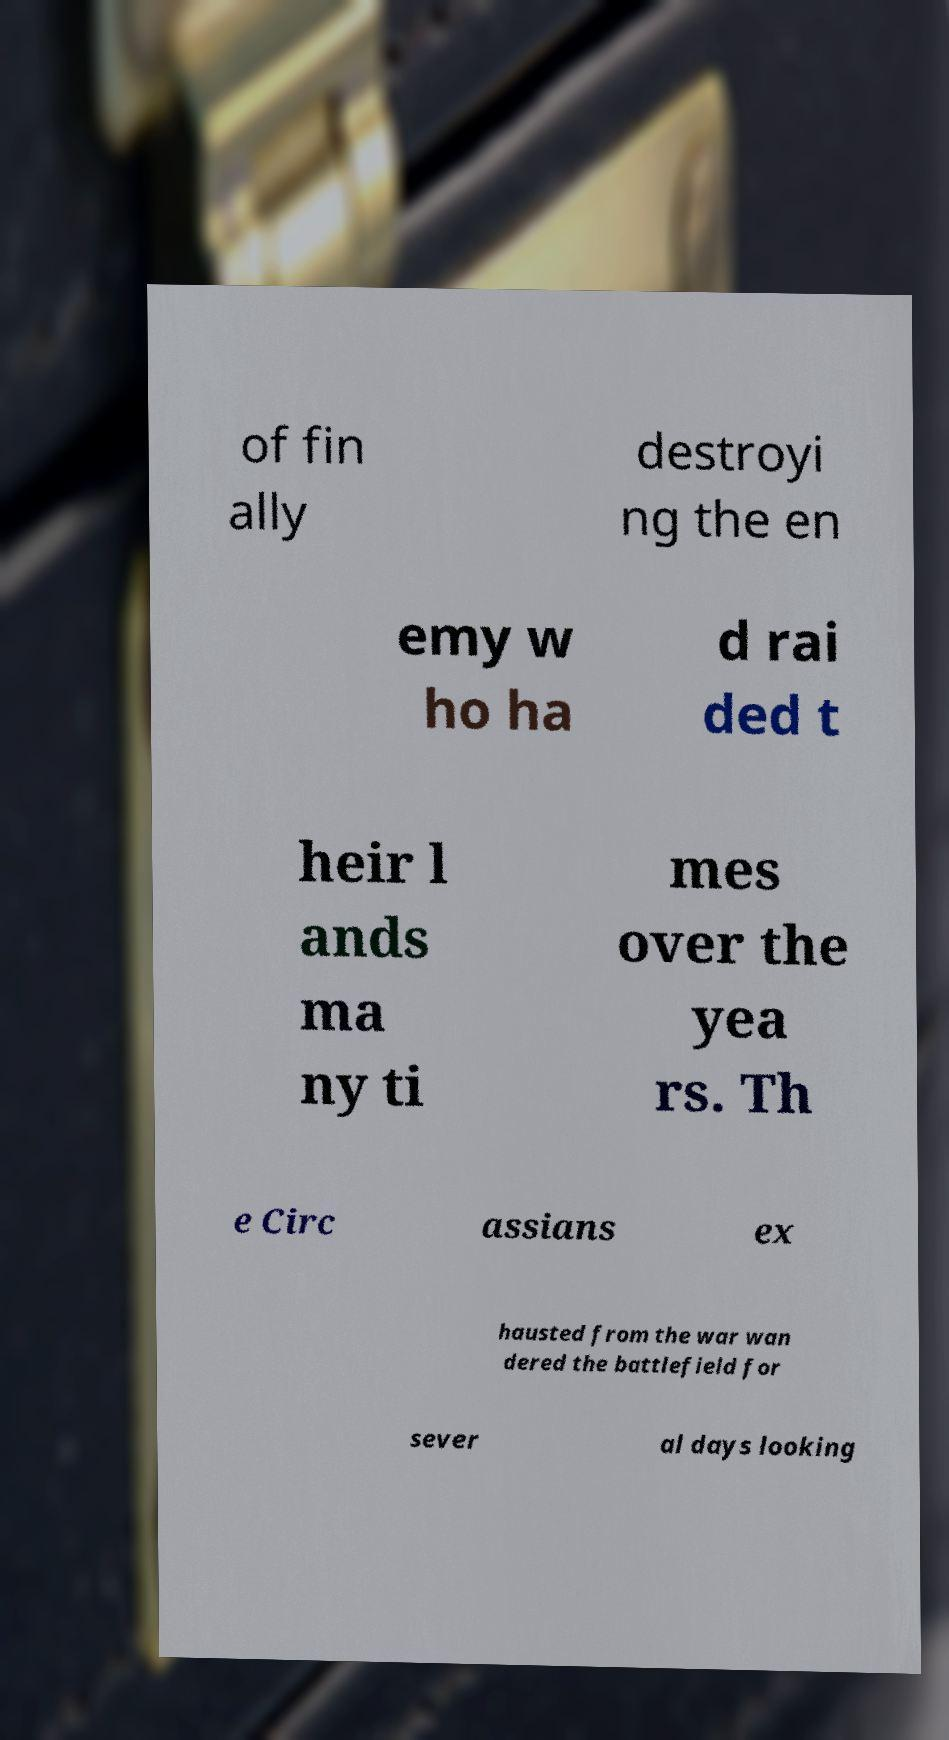Please read and relay the text visible in this image. What does it say? of fin ally destroyi ng the en emy w ho ha d rai ded t heir l ands ma ny ti mes over the yea rs. Th e Circ assians ex hausted from the war wan dered the battlefield for sever al days looking 